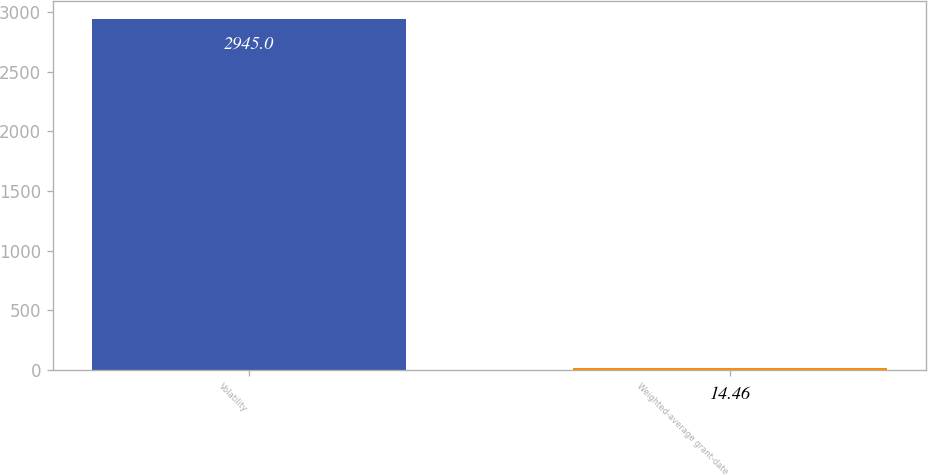Convert chart to OTSL. <chart><loc_0><loc_0><loc_500><loc_500><bar_chart><fcel>Volatility<fcel>Weighted-average grant-date<nl><fcel>2945<fcel>14.46<nl></chart> 